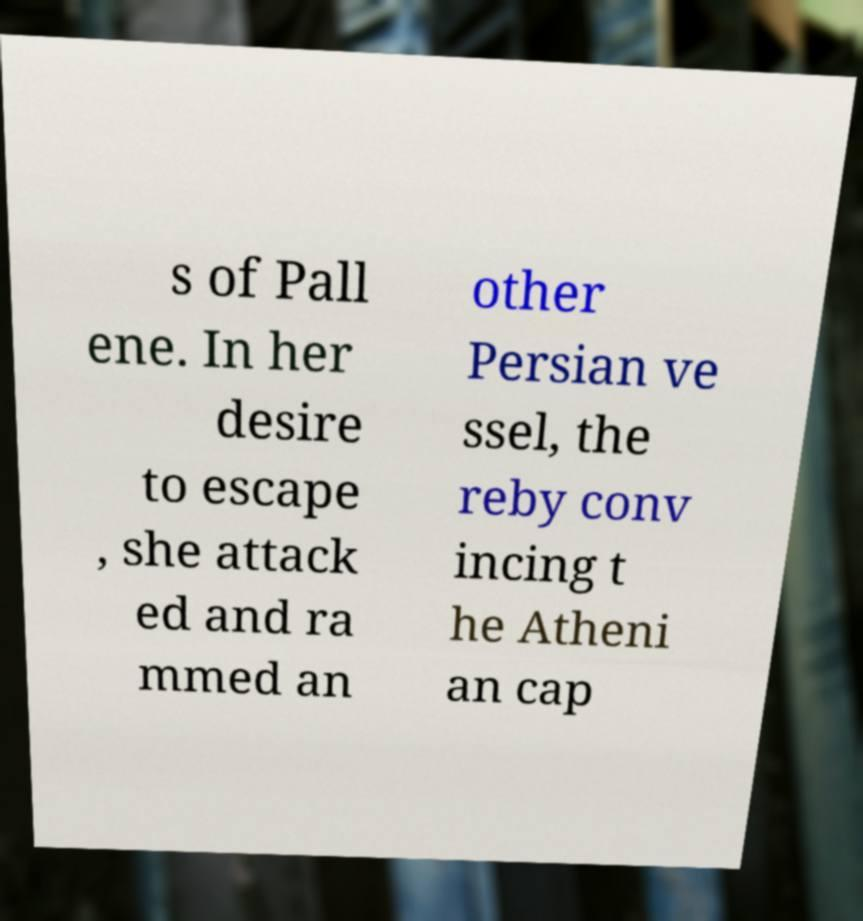Could you assist in decoding the text presented in this image and type it out clearly? s of Pall ene. In her desire to escape , she attack ed and ra mmed an other Persian ve ssel, the reby conv incing t he Atheni an cap 